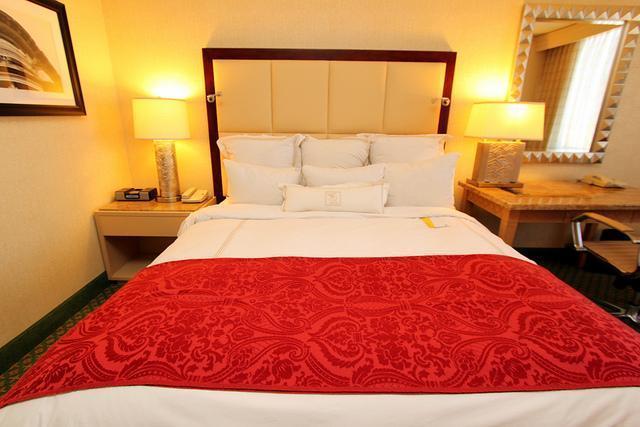How many pillows are on the bed?
Give a very brief answer. 7. 